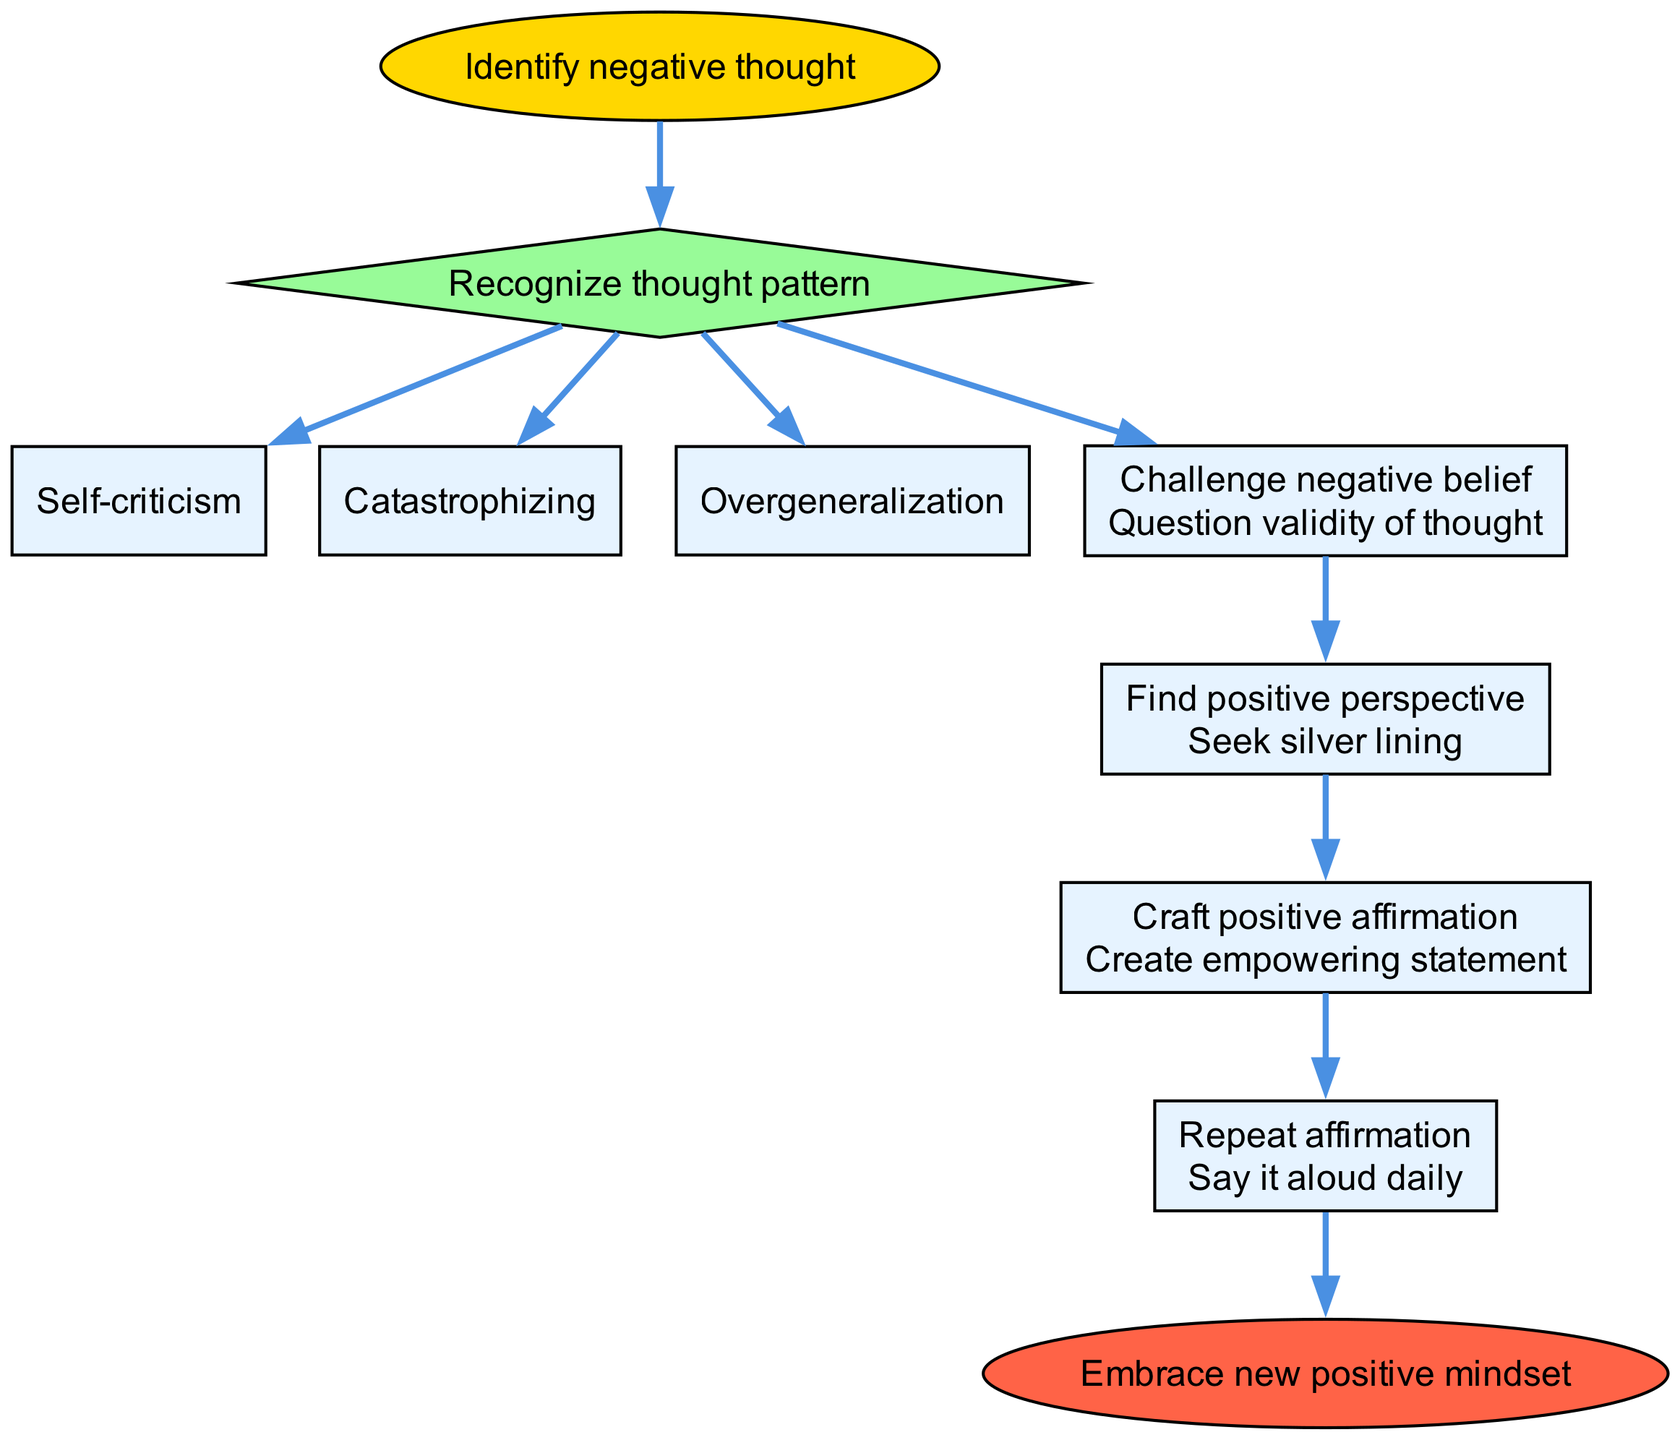What is the starting point of the flow chart? The flow chart starts with the node labeled "Identify negative thought", which is connected from the start node.
Answer: Identify negative thought How many steps are there in the process? There are five steps in the process, which are represented as nodes following the start node.
Answer: 5 What type of node is "Recognize thought pattern"? "Recognize thought pattern" is a decision node, represented by a diamond shape, indicating it has options to choose from.
Answer: Diamond What is the final outcome of this flow chart? The flow chart ends with the node labeled “Embrace new positive mindset”, which signifies the successful transformation of thoughts.
Answer: Embrace new positive mindset Which step involves questioning the validity of thoughts? The “Challenge negative belief” step requires questioning the validity of the negative thought, forming a crucial part of the process.
Answer: Challenge negative belief What does the step "Craft positive affirmation" entail? This step includes creating an empowering statement that acts as a replacement for the negative thought identified earlier.
Answer: Create empowering statement What is the connection between “Find positive perspective” and “Craft positive affirmation”? “Find positive perspective” leads directly to “Craft positive affirmation,” indicating that finding a positive angle is necessary before creating the affirmation.
Answer: Direct connection How many options are provided under "Recognize thought pattern"? The step "Recognize thought pattern" provides three options, which are specific types of negative thought patterns people may encounter.
Answer: 3 What should be done after crafting positive affirmations? After crafting positive affirmations, the next step is to repeat the affirmations aloud daily to reinforce the positive mindset.
Answer: Repeat affirmation 